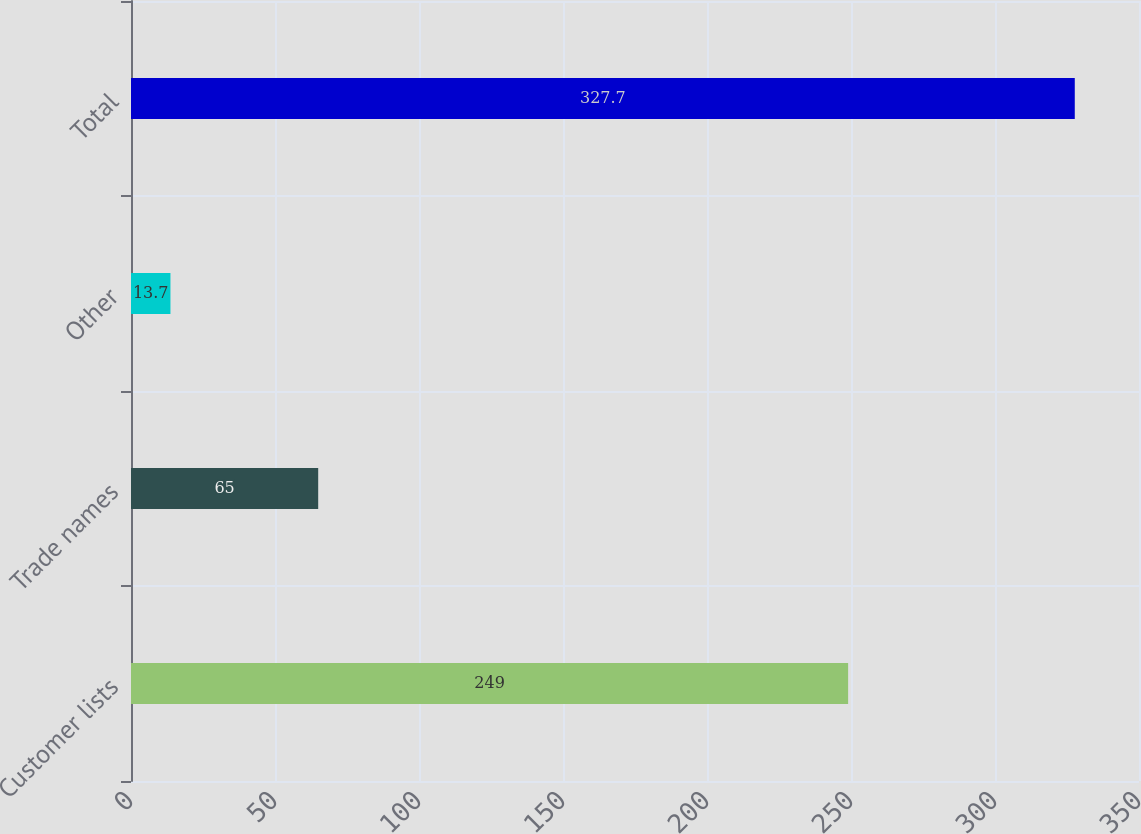<chart> <loc_0><loc_0><loc_500><loc_500><bar_chart><fcel>Customer lists<fcel>Trade names<fcel>Other<fcel>Total<nl><fcel>249<fcel>65<fcel>13.7<fcel>327.7<nl></chart> 